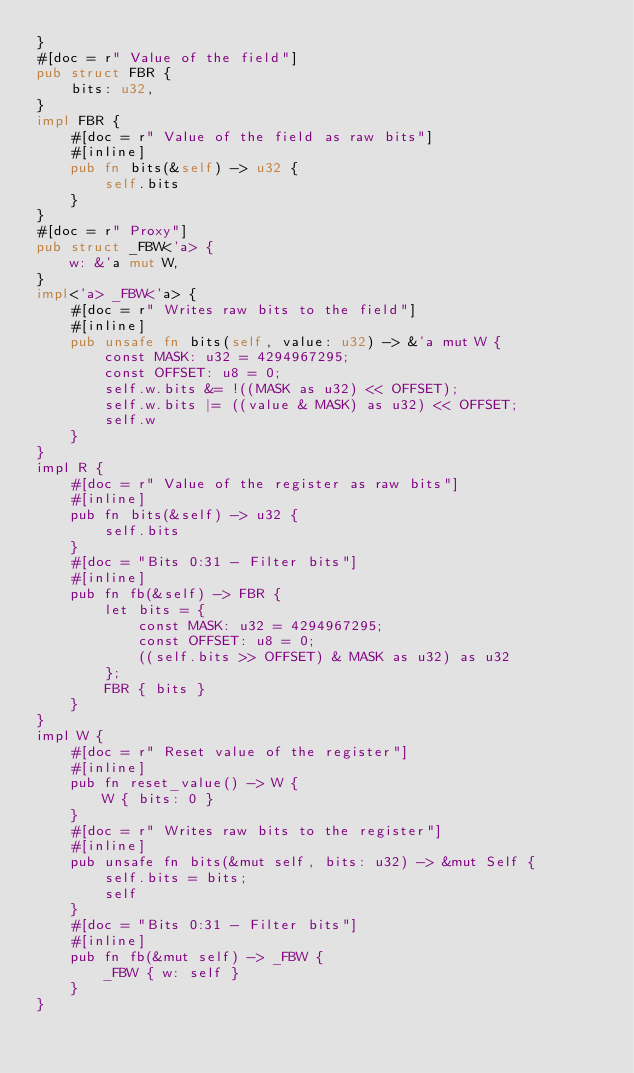<code> <loc_0><loc_0><loc_500><loc_500><_Rust_>}
#[doc = r" Value of the field"]
pub struct FBR {
    bits: u32,
}
impl FBR {
    #[doc = r" Value of the field as raw bits"]
    #[inline]
    pub fn bits(&self) -> u32 {
        self.bits
    }
}
#[doc = r" Proxy"]
pub struct _FBW<'a> {
    w: &'a mut W,
}
impl<'a> _FBW<'a> {
    #[doc = r" Writes raw bits to the field"]
    #[inline]
    pub unsafe fn bits(self, value: u32) -> &'a mut W {
        const MASK: u32 = 4294967295;
        const OFFSET: u8 = 0;
        self.w.bits &= !((MASK as u32) << OFFSET);
        self.w.bits |= ((value & MASK) as u32) << OFFSET;
        self.w
    }
}
impl R {
    #[doc = r" Value of the register as raw bits"]
    #[inline]
    pub fn bits(&self) -> u32 {
        self.bits
    }
    #[doc = "Bits 0:31 - Filter bits"]
    #[inline]
    pub fn fb(&self) -> FBR {
        let bits = {
            const MASK: u32 = 4294967295;
            const OFFSET: u8 = 0;
            ((self.bits >> OFFSET) & MASK as u32) as u32
        };
        FBR { bits }
    }
}
impl W {
    #[doc = r" Reset value of the register"]
    #[inline]
    pub fn reset_value() -> W {
        W { bits: 0 }
    }
    #[doc = r" Writes raw bits to the register"]
    #[inline]
    pub unsafe fn bits(&mut self, bits: u32) -> &mut Self {
        self.bits = bits;
        self
    }
    #[doc = "Bits 0:31 - Filter bits"]
    #[inline]
    pub fn fb(&mut self) -> _FBW {
        _FBW { w: self }
    }
}
</code> 